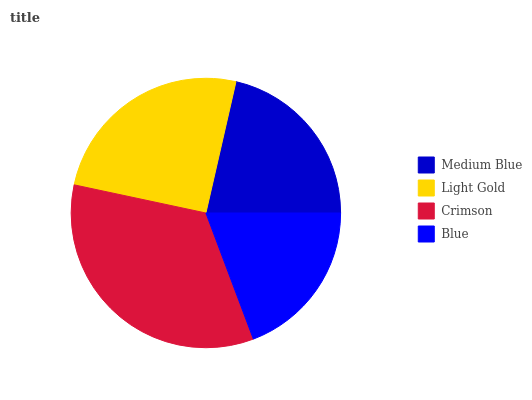Is Blue the minimum?
Answer yes or no. Yes. Is Crimson the maximum?
Answer yes or no. Yes. Is Light Gold the minimum?
Answer yes or no. No. Is Light Gold the maximum?
Answer yes or no. No. Is Light Gold greater than Medium Blue?
Answer yes or no. Yes. Is Medium Blue less than Light Gold?
Answer yes or no. Yes. Is Medium Blue greater than Light Gold?
Answer yes or no. No. Is Light Gold less than Medium Blue?
Answer yes or no. No. Is Light Gold the high median?
Answer yes or no. Yes. Is Medium Blue the low median?
Answer yes or no. Yes. Is Medium Blue the high median?
Answer yes or no. No. Is Crimson the low median?
Answer yes or no. No. 